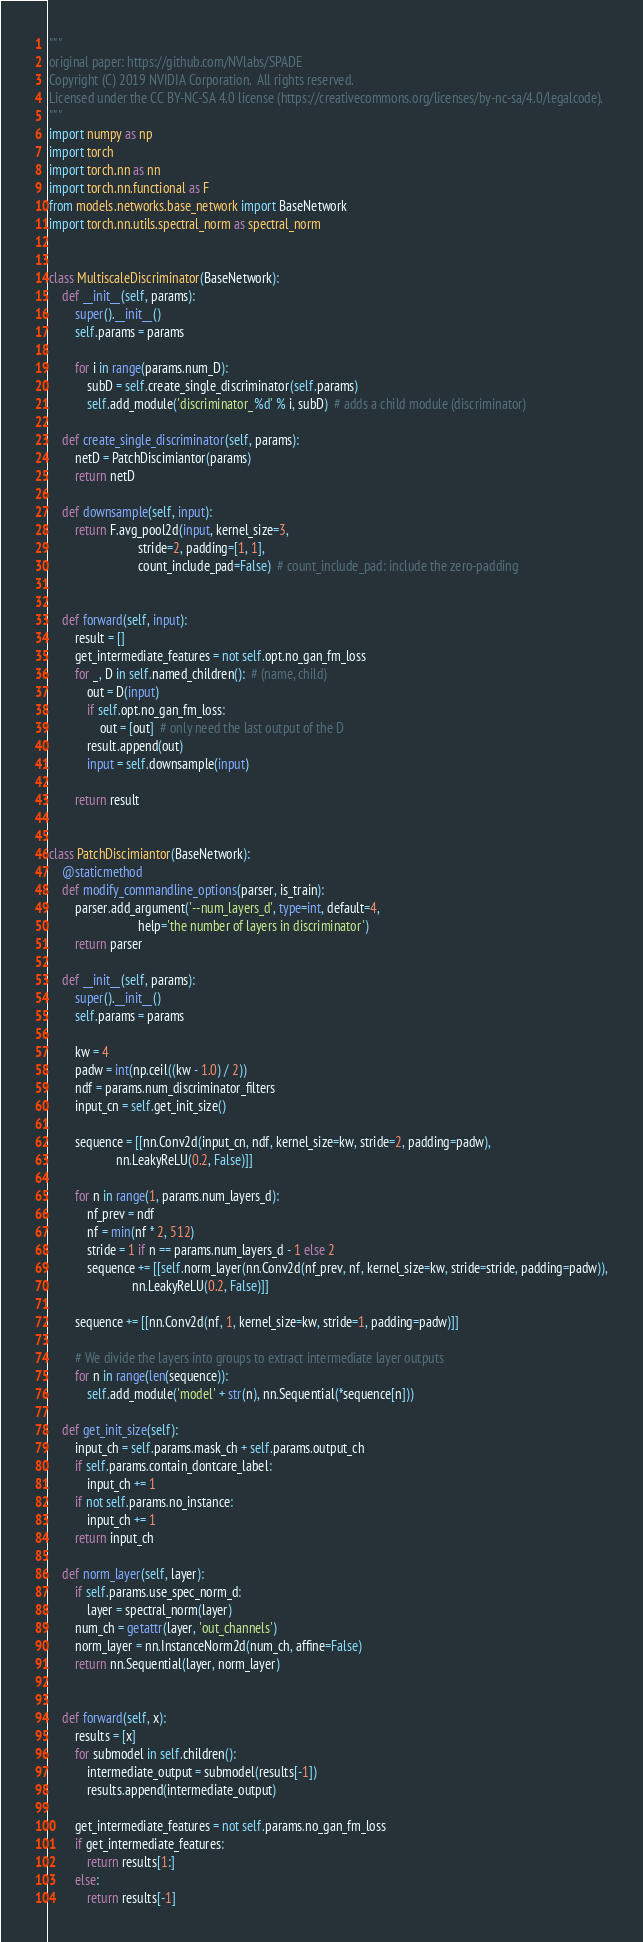Convert code to text. <code><loc_0><loc_0><loc_500><loc_500><_Python_>"""
original paper: https://github.com/NVlabs/SPADE
Copyright (C) 2019 NVIDIA Corporation.  All rights reserved.
Licensed under the CC BY-NC-SA 4.0 license (https://creativecommons.org/licenses/by-nc-sa/4.0/legalcode).
"""
import numpy as np
import torch
import torch.nn as nn
import torch.nn.functional as F
from models.networks.base_network import BaseNetwork
import torch.nn.utils.spectral_norm as spectral_norm


class MultiscaleDiscriminator(BaseNetwork):
    def __init__(self, params):
        super().__init__()
        self.params = params
        
        for i in range(params.num_D):
            subD = self.create_single_discriminator(self.params)
            self.add_module('discriminator_%d' % i, subD)  # adds a child module (discriminator)

    def create_single_discriminator(self, params):
        netD = PatchDiscimiantor(params)
        return netD

    def downsample(self, input):
        return F.avg_pool2d(input, kernel_size=3,
                            stride=2, padding=[1, 1],
                            count_include_pad=False)  # count_include_pad: include the zero-padding


    def forward(self, input):
        result = []
        get_intermediate_features = not self.opt.no_gan_fm_loss
        for _, D in self.named_children():  # (name, child)
            out = D(input)
            if self.opt.no_gan_fm_loss:
                out = [out]  # only need the last output of the D
            result.append(out)
            input = self.downsample(input)

        return result


class PatchDiscimiantor(BaseNetwork):
    @staticmethod
    def modify_commandline_options(parser, is_train):
        parser.add_argument('--num_layers_d', type=int, default=4,
                            help='the number of layers in discriminator')
        return parser
    
    def __init__(self, params):
        super().__init__()
        self.params = params

        kw = 4
        padw = int(np.ceil((kw - 1.0) / 2))
        ndf = params.num_discriminator_filters
        input_cn = self.get_init_size()

        sequence = [[nn.Conv2d(input_cn, ndf, kernel_size=kw, stride=2, padding=padw),
                     nn.LeakyReLU(0.2, False)]]

        for n in range(1, params.num_layers_d):
            nf_prev = ndf
            nf = min(nf * 2, 512)
            stride = 1 if n == params.num_layers_d - 1 else 2
            sequence += [[self.norm_layer(nn.Conv2d(nf_prev, nf, kernel_size=kw, stride=stride, padding=padw)),
                          nn.LeakyReLU(0.2, False)]]

        sequence += [[nn.Conv2d(nf, 1, kernel_size=kw, stride=1, padding=padw)]]

        # We divide the layers into groups to extract intermediate layer outputs
        for n in range(len(sequence)):
            self.add_module('model' + str(n), nn.Sequential(*sequence[n]))

    def get_init_size(self):
        input_ch = self.params.mask_ch + self.params.output_ch
        if self.params.contain_dontcare_label:
            input_ch += 1
        if not self.params.no_instance:
            input_ch += 1
        return input_ch       

    def norm_layer(self, layer):
        if self.params.use_spec_norm_d:
            layer = spectral_norm(layer)
        num_ch = getattr(layer, 'out_channels')
        norm_layer = nn.InstanceNorm2d(num_ch, affine=False)
        return nn.Sequential(layer, norm_layer)


    def forward(self, x):
        results = [x]
        for submodel in self.children():
            intermediate_output = submodel(results[-1])
            results.append(intermediate_output)

        get_intermediate_features = not self.params.no_gan_fm_loss
        if get_intermediate_features:
            return results[1:]
        else:
            return results[-1]</code> 